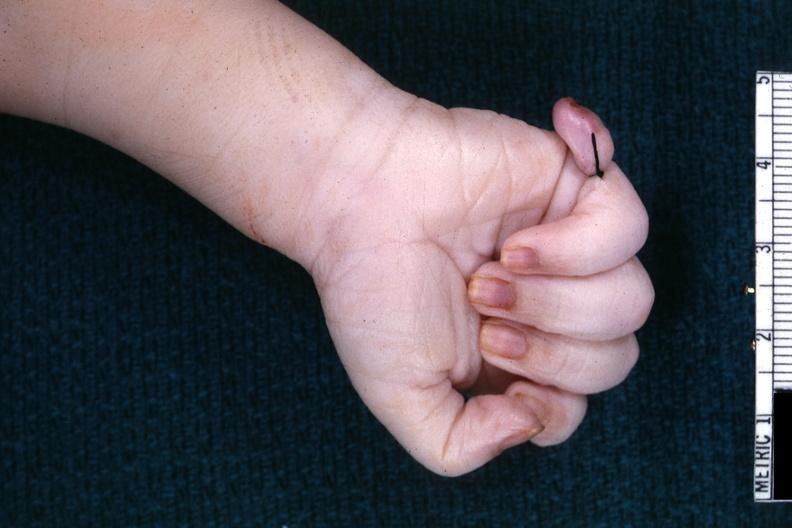re extremities present?
Answer the question using a single word or phrase. Yes 